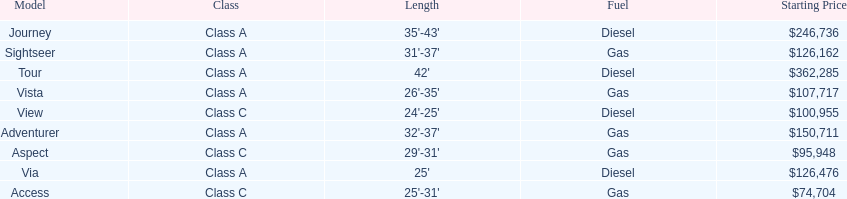How many models are available in lengths longer than 30 feet? 7. 